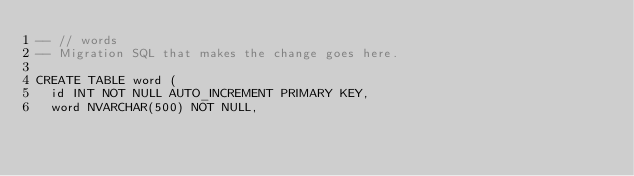<code> <loc_0><loc_0><loc_500><loc_500><_SQL_>-- // words
-- Migration SQL that makes the change goes here.

CREATE TABLE word (
	id INT NOT NULL AUTO_INCREMENT PRIMARY KEY,
	word NVARCHAR(500) NOT NULL,</code> 